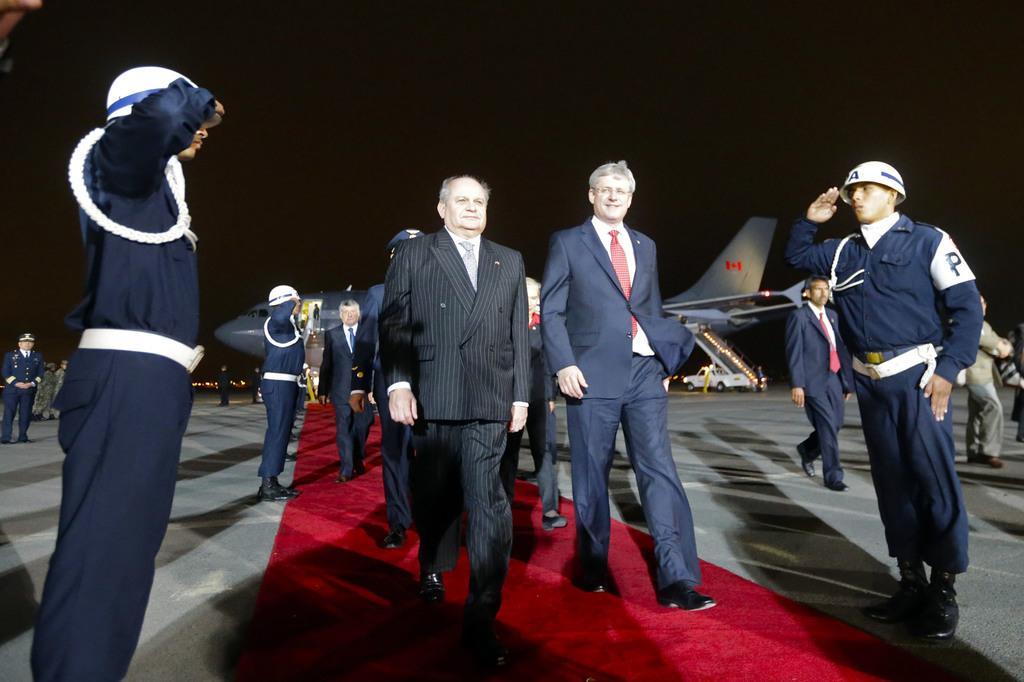In one or two sentences, can you explain what this image depicts? In this picture we can see ministers walking on the red carpet. On either side of the red carpet we have people saluting the ministers. In the background, we can see an airplane. 